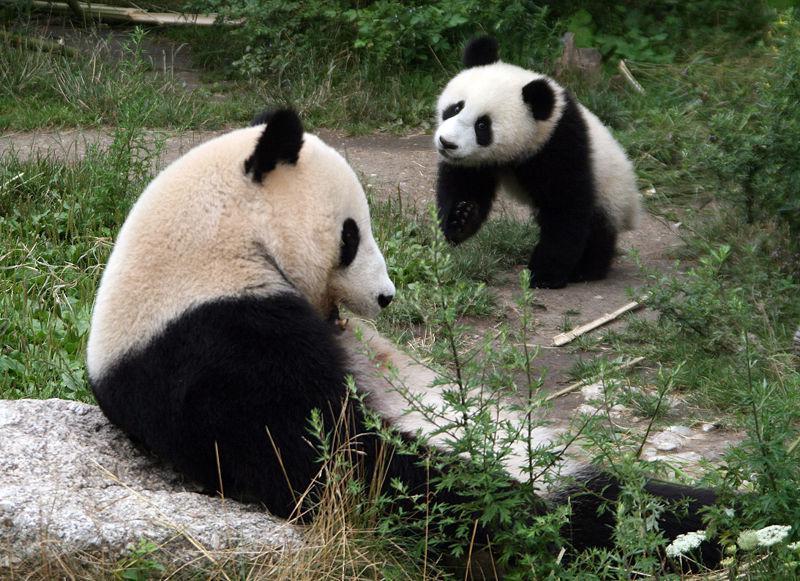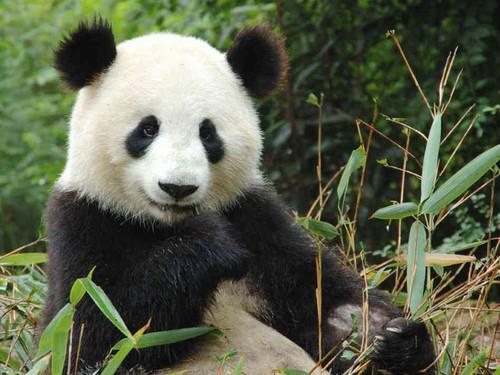The first image is the image on the left, the second image is the image on the right. For the images displayed, is the sentence "Two pandas are in a grassy area in the image on the left." factually correct? Answer yes or no. Yes. The first image is the image on the left, the second image is the image on the right. Examine the images to the left and right. Is the description "One image contains twice as many panda bears as the other image." accurate? Answer yes or no. Yes. 